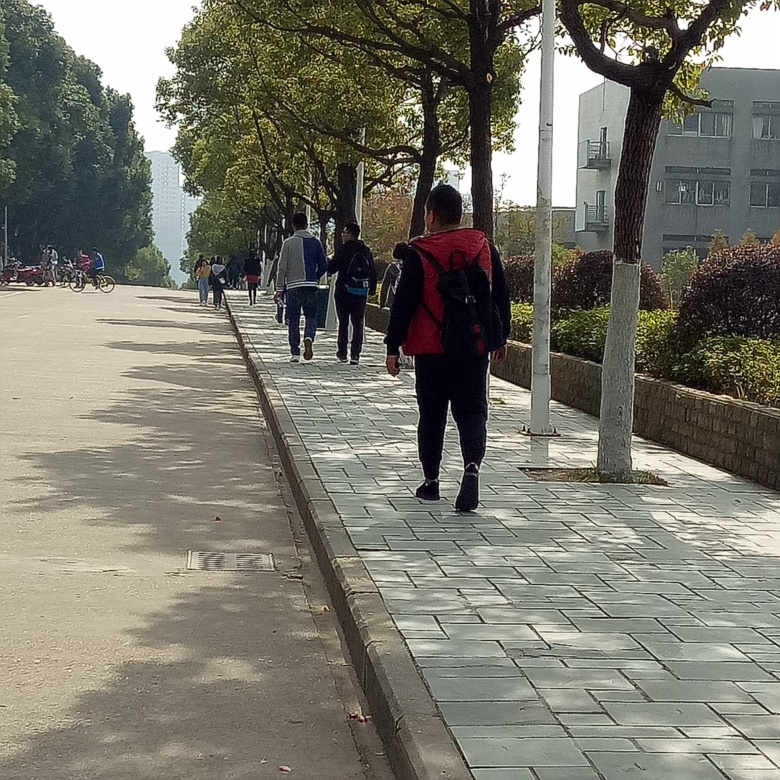Can you describe the mood of the scene? The mood of the scene is quite calm and routine. People are going about their day, walking and biking along a peaceful tree-lined sidewalk, which gives a sense of tranquility and everyday life. 